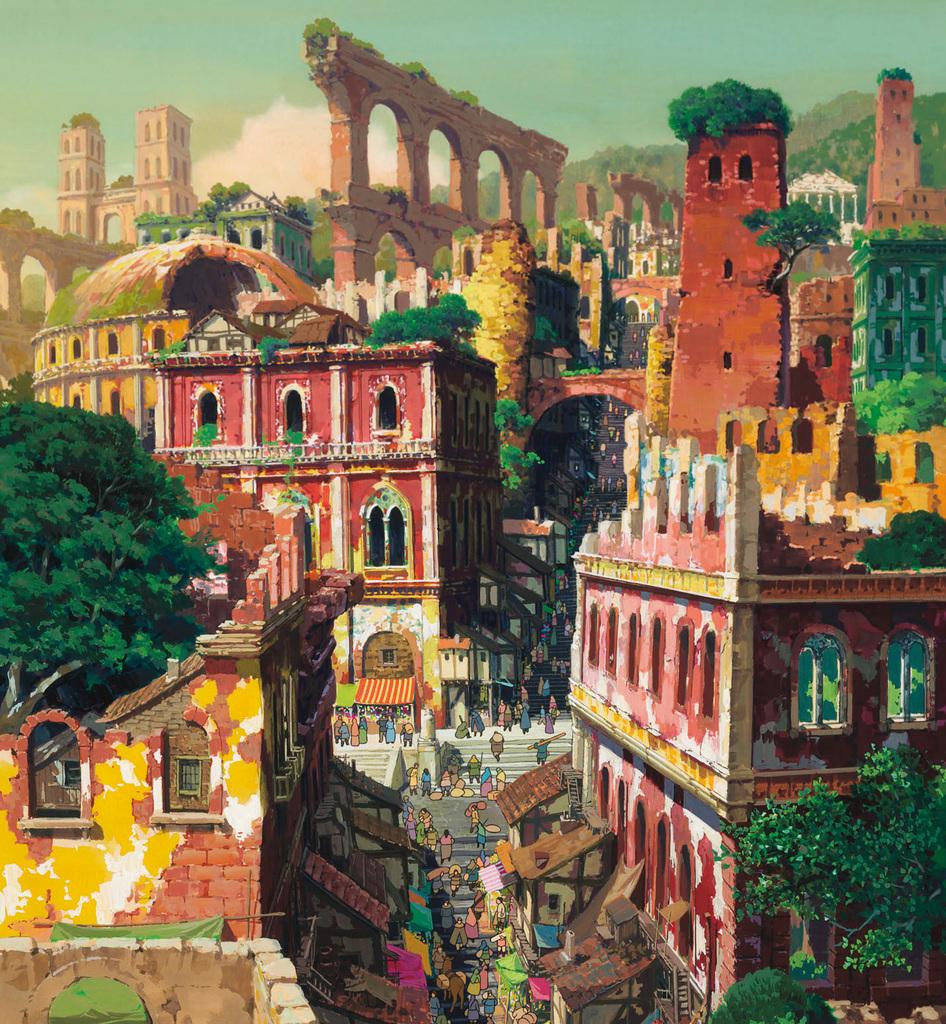What is the main subject of the image? The image contains a painting. What is being depicted in the painting? The painting depicts multiple buildings. Are there any natural elements in the painting? Yes, trees are present in the painting. What else can be seen in the painting? There are people on the road in the painting. What is visible in the background of the painting? The sky is visible in the background of the painting. How many mice are hiding behind the buildings in the painting? There are no mice present in the painting; it depicts buildings, trees, people, and the sky. 